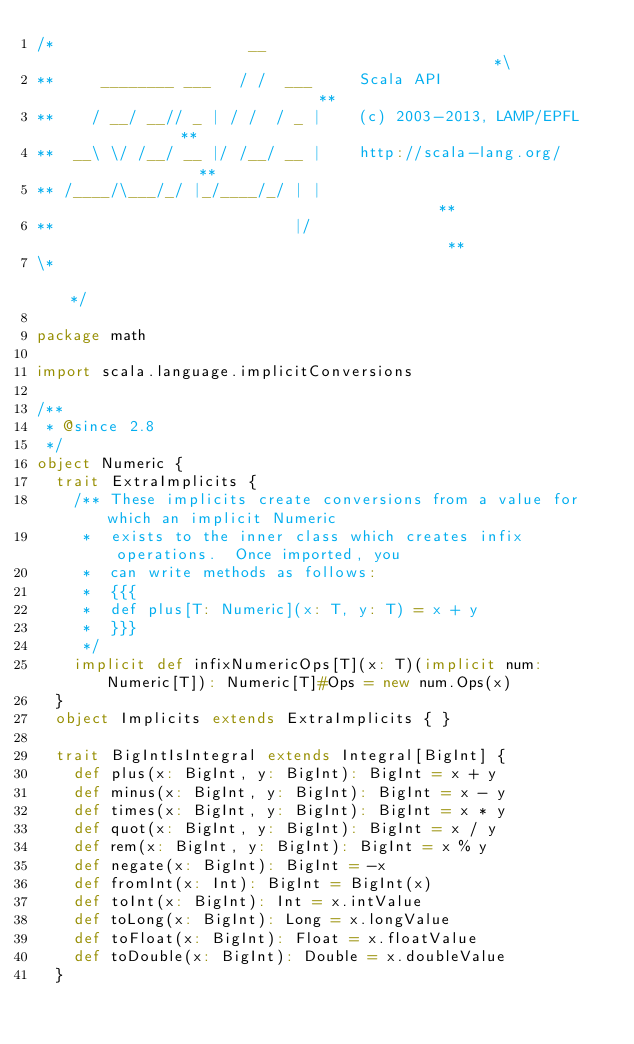Convert code to text. <code><loc_0><loc_0><loc_500><loc_500><_Scala_>/*                     __                                               *\
**     ________ ___   / /  ___     Scala API                            **
**    / __/ __// _ | / /  / _ |    (c) 2003-2013, LAMP/EPFL             **
**  __\ \/ /__/ __ |/ /__/ __ |    http://scala-lang.org/               **
** /____/\___/_/ |_/____/_/ | |                                         **
**                          |/                                          **
\*                                                                      */

package math

import scala.language.implicitConversions

/**
 * @since 2.8
 */
object Numeric {
  trait ExtraImplicits {
    /** These implicits create conversions from a value for which an implicit Numeric
     *  exists to the inner class which creates infix operations.  Once imported, you
     *  can write methods as follows:
     *  {{{
     *  def plus[T: Numeric](x: T, y: T) = x + y
     *  }}}
     */
    implicit def infixNumericOps[T](x: T)(implicit num: Numeric[T]): Numeric[T]#Ops = new num.Ops(x)
  }
  object Implicits extends ExtraImplicits { }

  trait BigIntIsIntegral extends Integral[BigInt] {
    def plus(x: BigInt, y: BigInt): BigInt = x + y
    def minus(x: BigInt, y: BigInt): BigInt = x - y
    def times(x: BigInt, y: BigInt): BigInt = x * y
    def quot(x: BigInt, y: BigInt): BigInt = x / y
    def rem(x: BigInt, y: BigInt): BigInt = x % y
    def negate(x: BigInt): BigInt = -x
    def fromInt(x: Int): BigInt = BigInt(x)
    def toInt(x: BigInt): Int = x.intValue
    def toLong(x: BigInt): Long = x.longValue
    def toFloat(x: BigInt): Float = x.floatValue
    def toDouble(x: BigInt): Double = x.doubleValue
  }</code> 